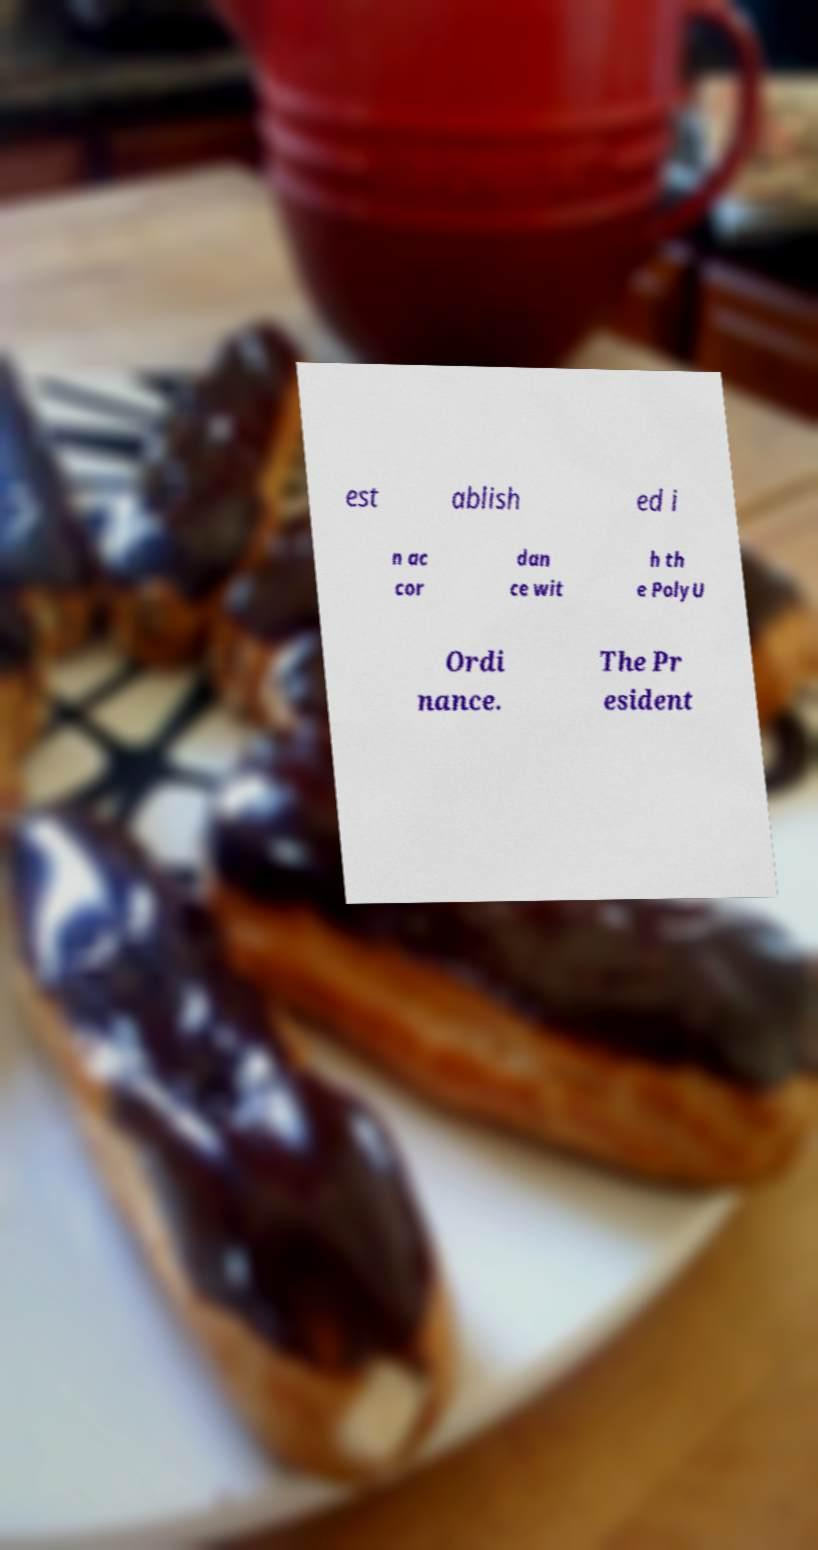For documentation purposes, I need the text within this image transcribed. Could you provide that? est ablish ed i n ac cor dan ce wit h th e PolyU Ordi nance. The Pr esident 